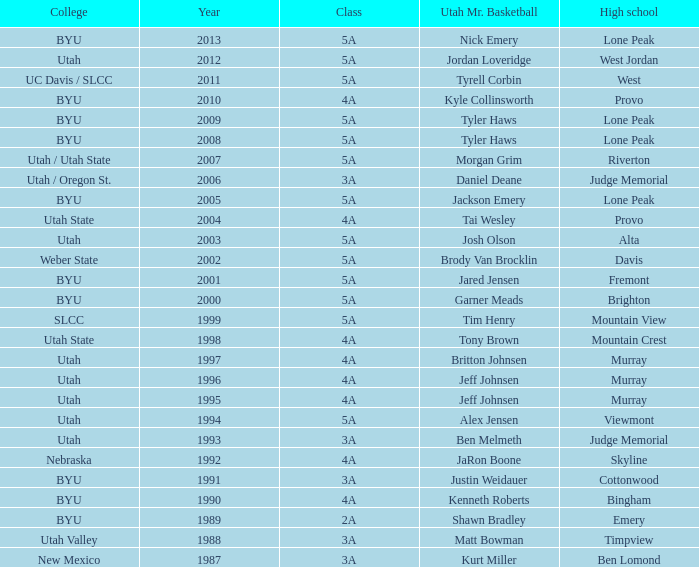Where did Tyler Haws, 2009 Utah Mr. Basketball, go to high school? Lone Peak. 